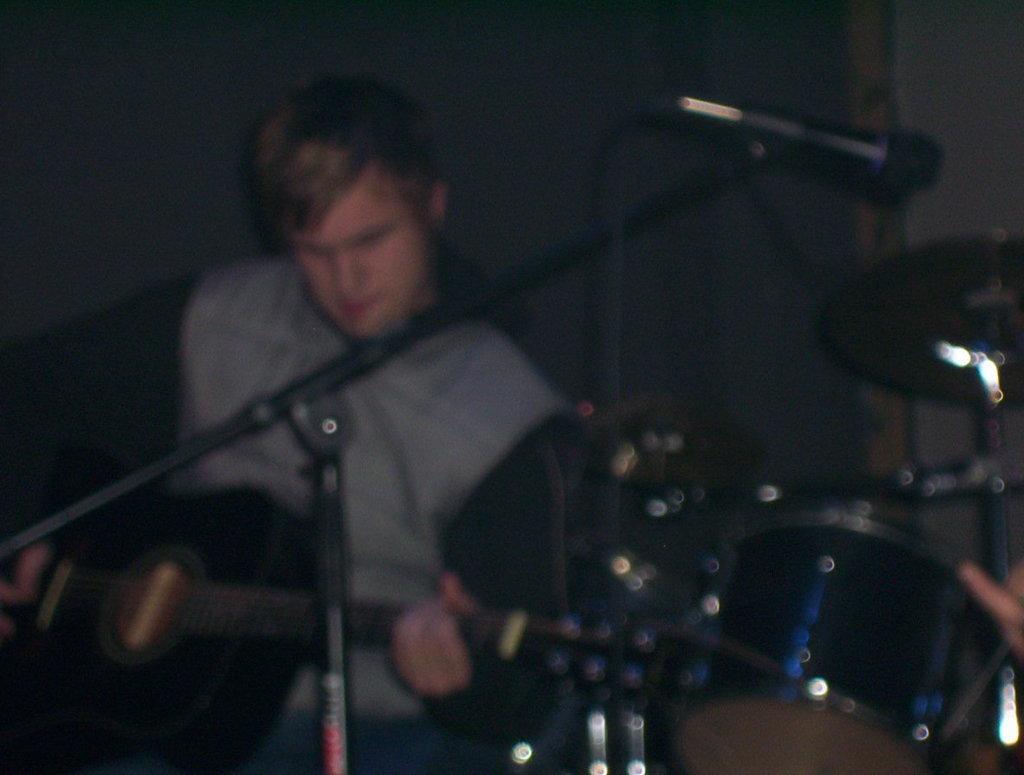Could you give a brief overview of what you see in this image? In the center of the image there is a man standing and holding a guitar in his hand. There is a mic placed before him. On the right side of the image there is a band. 